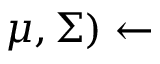Convert formula to latex. <formula><loc_0><loc_0><loc_500><loc_500>\mu , \Sigma ) \leftarrow</formula> 